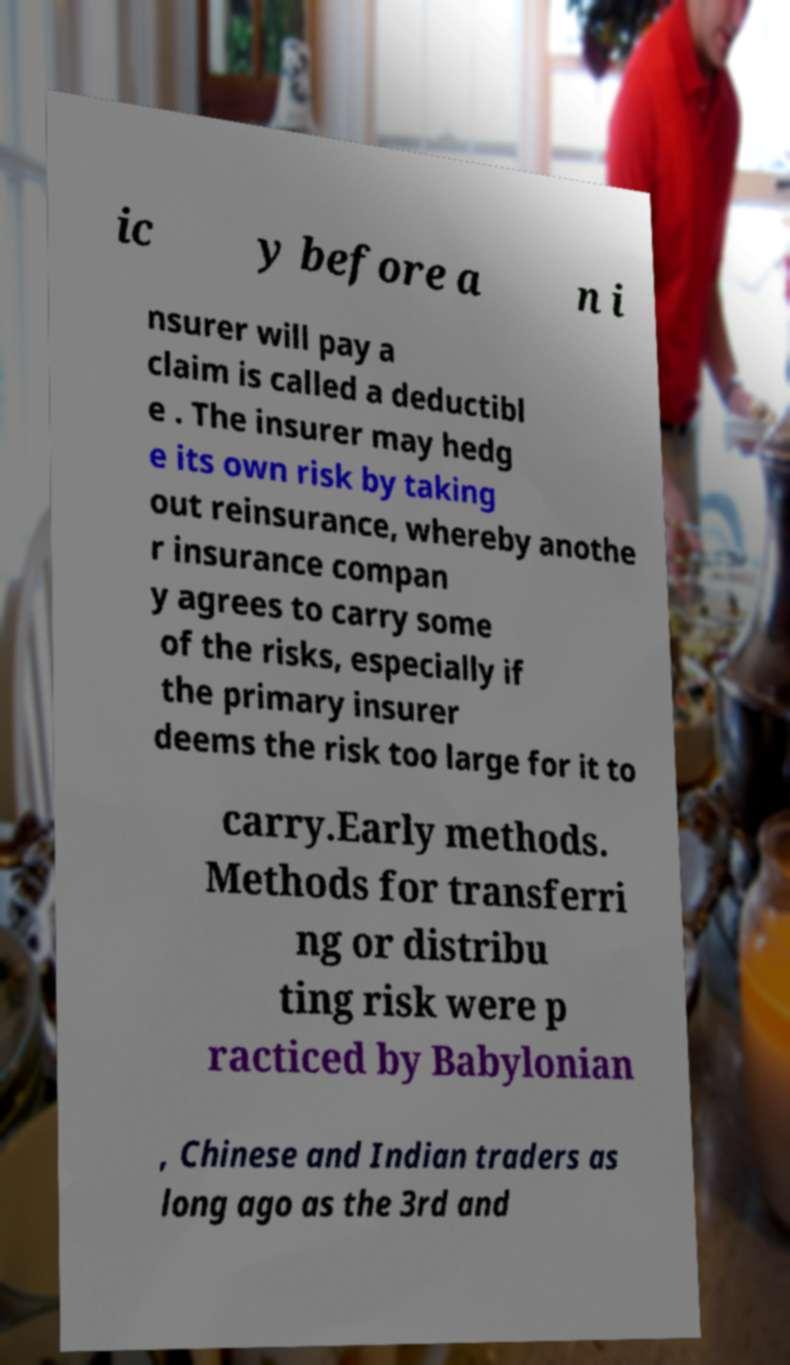Can you read and provide the text displayed in the image?This photo seems to have some interesting text. Can you extract and type it out for me? ic y before a n i nsurer will pay a claim is called a deductibl e . The insurer may hedg e its own risk by taking out reinsurance, whereby anothe r insurance compan y agrees to carry some of the risks, especially if the primary insurer deems the risk too large for it to carry.Early methods. Methods for transferri ng or distribu ting risk were p racticed by Babylonian , Chinese and Indian traders as long ago as the 3rd and 